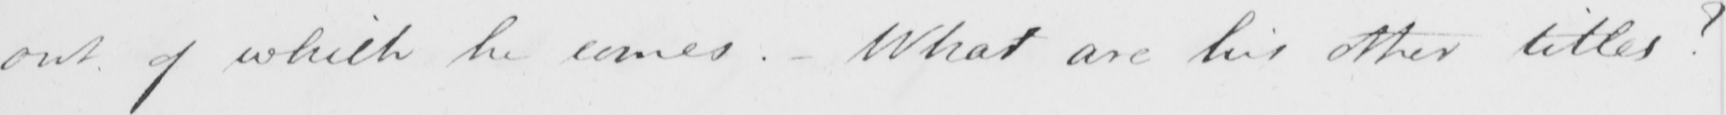Transcribe the text shown in this historical manuscript line. out of which he comes . - What are his other titles ? 